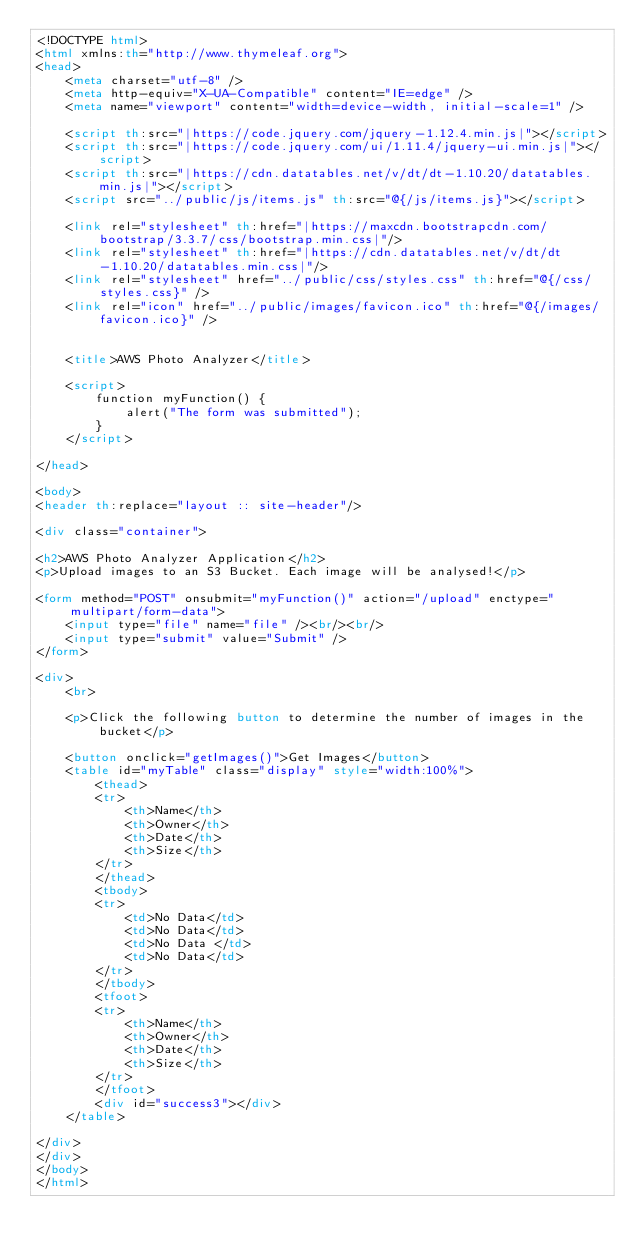<code> <loc_0><loc_0><loc_500><loc_500><_HTML_><!DOCTYPE html>
<html xmlns:th="http://www.thymeleaf.org">
<head>
    <meta charset="utf-8" />
    <meta http-equiv="X-UA-Compatible" content="IE=edge" />
    <meta name="viewport" content="width=device-width, initial-scale=1" />

    <script th:src="|https://code.jquery.com/jquery-1.12.4.min.js|"></script>
    <script th:src="|https://code.jquery.com/ui/1.11.4/jquery-ui.min.js|"></script>
    <script th:src="|https://cdn.datatables.net/v/dt/dt-1.10.20/datatables.min.js|"></script>
    <script src="../public/js/items.js" th:src="@{/js/items.js}"></script>

    <link rel="stylesheet" th:href="|https://maxcdn.bootstrapcdn.com/bootstrap/3.3.7/css/bootstrap.min.css|"/>
    <link rel="stylesheet" th:href="|https://cdn.datatables.net/v/dt/dt-1.10.20/datatables.min.css|"/>
    <link rel="stylesheet" href="../public/css/styles.css" th:href="@{/css/styles.css}" />
    <link rel="icon" href="../public/images/favicon.ico" th:href="@{/images/favicon.ico}" />


    <title>AWS Photo Analyzer</title>

    <script>
        function myFunction() {
            alert("The form was submitted");
        }
    </script>

</head>

<body>
<header th:replace="layout :: site-header"/>

<div class="container">

<h2>AWS Photo Analyzer Application</h2>
<p>Upload images to an S3 Bucket. Each image will be analysed!</p>

<form method="POST" onsubmit="myFunction()" action="/upload" enctype="multipart/form-data">
    <input type="file" name="file" /><br/><br/>
    <input type="submit" value="Submit" />
</form>

<div>
    <br>

    <p>Click the following button to determine the number of images in the bucket</p>

    <button onclick="getImages()">Get Images</button>
    <table id="myTable" class="display" style="width:100%">
        <thead>
        <tr>
            <th>Name</th>
            <th>Owner</th>
            <th>Date</th>
            <th>Size</th>
        </tr>
        </thead>
        <tbody>
        <tr>
            <td>No Data</td>
            <td>No Data</td>
            <td>No Data </td>
            <td>No Data</td>
        </tr>
        </tbody>
        <tfoot>
        <tr>
            <th>Name</th>
            <th>Owner</th>
            <th>Date</th>
            <th>Size</th>
        </tr>
        </tfoot>
        <div id="success3"></div>
    </table>

</div>
</div>
</body>
</html>
</code> 